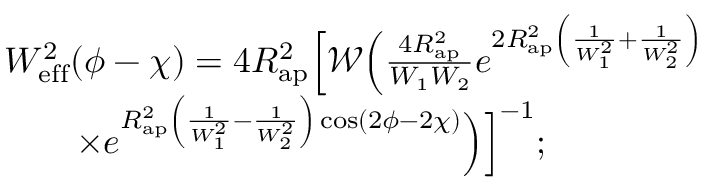<formula> <loc_0><loc_0><loc_500><loc_500>\begin{array} { r l } & { W _ { e f f } ^ { 2 } ( \phi - \chi ) = 4 R _ { a p } ^ { 2 } \left [ \mathcal { W } \left ( \frac { 4 R _ { a p } ^ { 2 } } { W _ { 1 } W _ { 2 } } e ^ { 2 R _ { a p } ^ { 2 } \left ( \frac { 1 } { W _ { 1 } ^ { 2 } } + \frac { 1 } { W _ { 2 } ^ { 2 } } \right ) } \Big . \Big . } \\ & { \quad \times \Big . \Big . e ^ { R _ { a p } ^ { 2 } \left ( \frac { 1 } { W _ { 1 } ^ { 2 } } - \frac { 1 } { W _ { 2 } ^ { 2 } } \right ) \cos ( 2 \phi - 2 \chi ) } \right ) \right ] ^ { - 1 } ; } \end{array}</formula> 